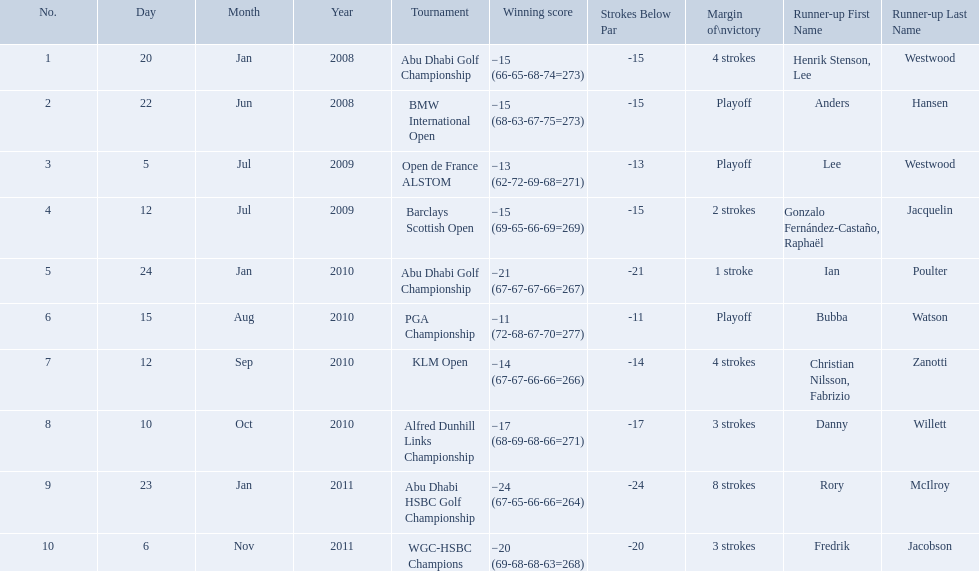How many strokes were in the klm open by martin kaymer? 4 strokes. How many strokes were in the abu dhabi golf championship? 4 strokes. How many more strokes were there in the klm than the barclays open? 2 strokes. Write the full table. {'header': ['No.', 'Day', 'Month', 'Year', 'Tournament', 'Winning score', 'Strokes Below Par', 'Margin of\\nvictory', 'Runner-up First Name', 'Runner-up Last Name'], 'rows': [['1', '20', 'Jan', '2008', 'Abu Dhabi Golf Championship', '−15 (66-65-68-74=273)', '-15', '4 strokes', 'Henrik Stenson, Lee', 'Westwood'], ['2', '22', 'Jun', '2008', 'BMW International Open', '−15 (68-63-67-75=273)', '-15', 'Playoff', 'Anders', 'Hansen'], ['3', '5', 'Jul', '2009', 'Open de France ALSTOM', '−13 (62-72-69-68=271)', '-13', 'Playoff', 'Lee', 'Westwood'], ['4', '12', 'Jul', '2009', 'Barclays Scottish Open', '−15 (69-65-66-69=269)', '-15', '2 strokes', 'Gonzalo Fernández-Castaño, Raphaël', 'Jacquelin'], ['5', '24', 'Jan', '2010', 'Abu Dhabi Golf Championship', '−21 (67-67-67-66=267)', '-21', '1 stroke', 'Ian', 'Poulter'], ['6', '15', 'Aug', '2010', 'PGA Championship', '−11 (72-68-67-70=277)', '-11', 'Playoff', 'Bubba', 'Watson'], ['7', '12', 'Sep', '2010', 'KLM Open', '−14 (67-67-66-66=266)', '-14', '4 strokes', 'Christian Nilsson, Fabrizio', 'Zanotti'], ['8', '10', 'Oct', '2010', 'Alfred Dunhill Links Championship', '−17 (68-69-68-66=271)', '-17', '3 strokes', 'Danny', 'Willett'], ['9', '23', 'Jan', '2011', 'Abu Dhabi HSBC Golf Championship', '−24 (67-65-66-66=264)', '-24', '8 strokes', 'Rory', 'McIlroy'], ['10', '6', 'Nov', '2011', 'WGC-HSBC Champions', '−20 (69-68-68-63=268)', '-20', '3 strokes', 'Fredrik', 'Jacobson']]} What are all of the tournaments? Abu Dhabi Golf Championship, BMW International Open, Open de France ALSTOM, Barclays Scottish Open, Abu Dhabi Golf Championship, PGA Championship, KLM Open, Alfred Dunhill Links Championship, Abu Dhabi HSBC Golf Championship, WGC-HSBC Champions. What was the score during each? −15 (66-65-68-74=273), −15 (68-63-67-75=273), −13 (62-72-69-68=271), −15 (69-65-66-69=269), −21 (67-67-67-66=267), −11 (72-68-67-70=277), −14 (67-67-66-66=266), −17 (68-69-68-66=271), −24 (67-65-66-66=264), −20 (69-68-68-63=268). And who was the runner-up in each? Henrik Stenson, Lee Westwood, Anders Hansen, Lee Westwood, Gonzalo Fernández-Castaño, Raphaël Jacquelin, Ian Poulter, Bubba Watson, Christian Nilsson, Fabrizio Zanotti, Danny Willett, Rory McIlroy, Fredrik Jacobson. What about just during pga games? Bubba Watson. 